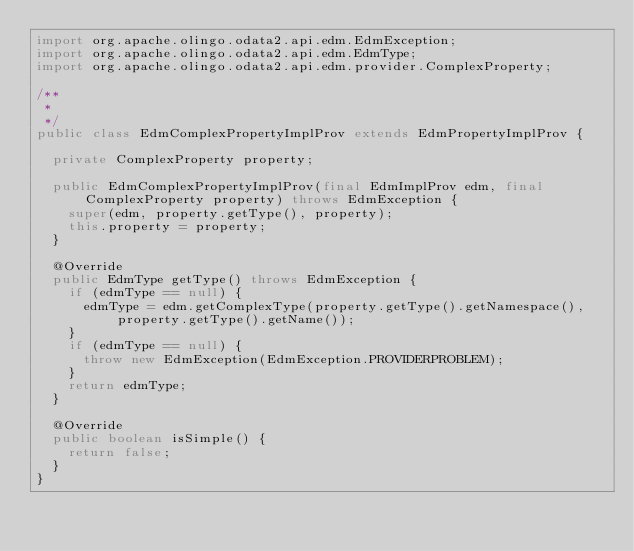<code> <loc_0><loc_0><loc_500><loc_500><_Java_>import org.apache.olingo.odata2.api.edm.EdmException;
import org.apache.olingo.odata2.api.edm.EdmType;
import org.apache.olingo.odata2.api.edm.provider.ComplexProperty;

/**
 *  
 */
public class EdmComplexPropertyImplProv extends EdmPropertyImplProv {

  private ComplexProperty property;

  public EdmComplexPropertyImplProv(final EdmImplProv edm, final ComplexProperty property) throws EdmException {
    super(edm, property.getType(), property);
    this.property = property;
  }

  @Override
  public EdmType getType() throws EdmException {
    if (edmType == null) {
      edmType = edm.getComplexType(property.getType().getNamespace(), property.getType().getName());
    }
    if (edmType == null) {
      throw new EdmException(EdmException.PROVIDERPROBLEM);
    }
    return edmType;
  }

  @Override
  public boolean isSimple() {
    return false;
  }
}
</code> 